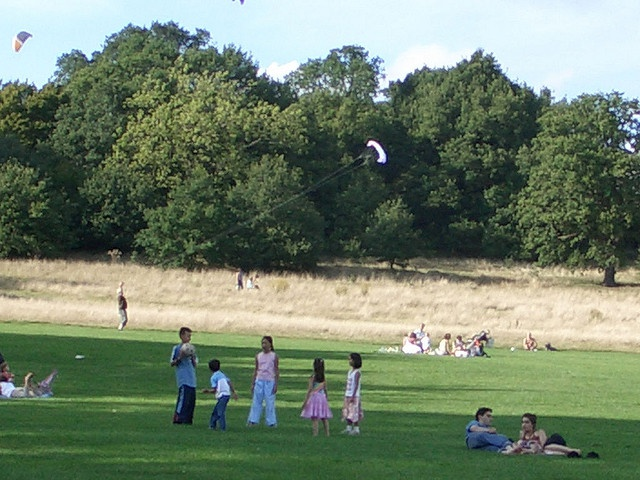Describe the objects in this image and their specific colors. I can see people in white, gray, and darkgray tones, people in white, black, gray, and blue tones, people in white, gray, black, darkgray, and darkgreen tones, people in white, gray, blue, black, and navy tones, and people in white, gray, violet, black, and purple tones in this image. 